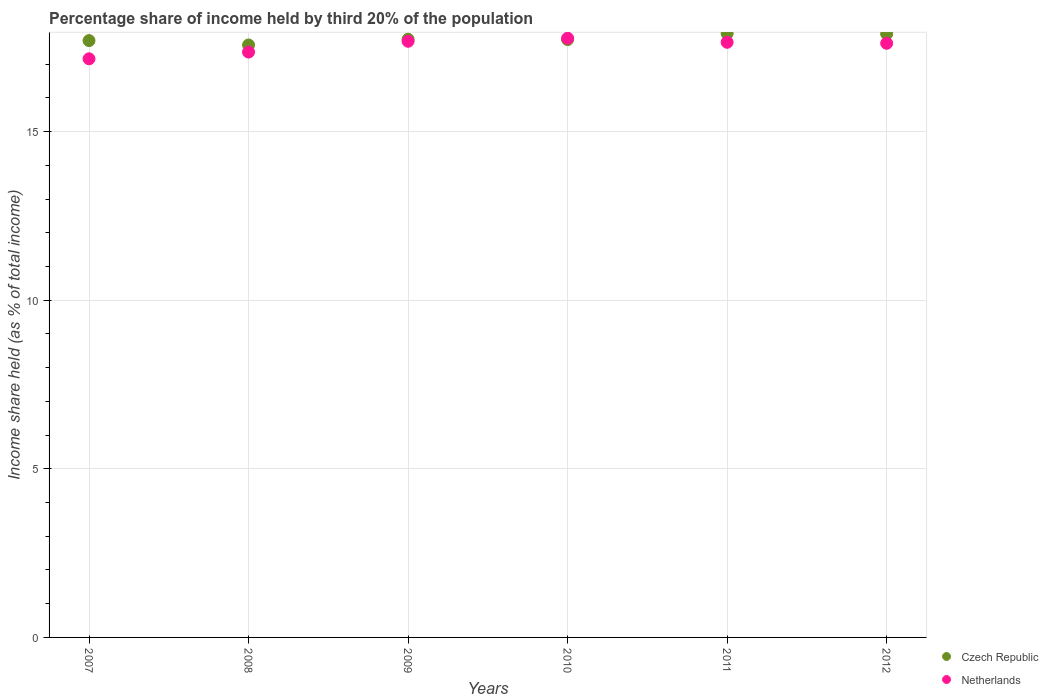Is the number of dotlines equal to the number of legend labels?
Ensure brevity in your answer.  Yes. What is the share of income held by third 20% of the population in Czech Republic in 2009?
Provide a succinct answer. 17.74. Across all years, what is the maximum share of income held by third 20% of the population in Czech Republic?
Your answer should be very brief. 17.91. Across all years, what is the minimum share of income held by third 20% of the population in Czech Republic?
Provide a short and direct response. 17.57. What is the total share of income held by third 20% of the population in Netherlands in the graph?
Make the answer very short. 105.24. What is the difference between the share of income held by third 20% of the population in Czech Republic in 2008 and that in 2010?
Your answer should be very brief. -0.16. What is the difference between the share of income held by third 20% of the population in Netherlands in 2008 and the share of income held by third 20% of the population in Czech Republic in 2009?
Your response must be concise. -0.38. What is the average share of income held by third 20% of the population in Netherlands per year?
Provide a succinct answer. 17.54. In the year 2010, what is the difference between the share of income held by third 20% of the population in Netherlands and share of income held by third 20% of the population in Czech Republic?
Ensure brevity in your answer.  0.04. What is the ratio of the share of income held by third 20% of the population in Netherlands in 2009 to that in 2010?
Offer a terse response. 0.99. Is the difference between the share of income held by third 20% of the population in Netherlands in 2007 and 2009 greater than the difference between the share of income held by third 20% of the population in Czech Republic in 2007 and 2009?
Offer a very short reply. No. What is the difference between the highest and the second highest share of income held by third 20% of the population in Netherlands?
Your response must be concise. 0.09. What is the difference between the highest and the lowest share of income held by third 20% of the population in Netherlands?
Ensure brevity in your answer.  0.61. Is the sum of the share of income held by third 20% of the population in Czech Republic in 2007 and 2012 greater than the maximum share of income held by third 20% of the population in Netherlands across all years?
Give a very brief answer. Yes. Is the share of income held by third 20% of the population in Czech Republic strictly less than the share of income held by third 20% of the population in Netherlands over the years?
Your answer should be compact. No. How many years are there in the graph?
Ensure brevity in your answer.  6. What is the difference between two consecutive major ticks on the Y-axis?
Your answer should be very brief. 5. Where does the legend appear in the graph?
Keep it short and to the point. Bottom right. How many legend labels are there?
Make the answer very short. 2. What is the title of the graph?
Offer a very short reply. Percentage share of income held by third 20% of the population. Does "Germany" appear as one of the legend labels in the graph?
Give a very brief answer. No. What is the label or title of the Y-axis?
Keep it short and to the point. Income share held (as % of total income). What is the Income share held (as % of total income) in Czech Republic in 2007?
Make the answer very short. 17.7. What is the Income share held (as % of total income) of Netherlands in 2007?
Make the answer very short. 17.16. What is the Income share held (as % of total income) in Czech Republic in 2008?
Keep it short and to the point. 17.57. What is the Income share held (as % of total income) in Netherlands in 2008?
Provide a succinct answer. 17.36. What is the Income share held (as % of total income) in Czech Republic in 2009?
Offer a very short reply. 17.74. What is the Income share held (as % of total income) in Netherlands in 2009?
Make the answer very short. 17.68. What is the Income share held (as % of total income) in Czech Republic in 2010?
Your answer should be compact. 17.73. What is the Income share held (as % of total income) in Netherlands in 2010?
Offer a very short reply. 17.77. What is the Income share held (as % of total income) in Czech Republic in 2011?
Ensure brevity in your answer.  17.91. What is the Income share held (as % of total income) in Netherlands in 2011?
Provide a short and direct response. 17.65. What is the Income share held (as % of total income) of Czech Republic in 2012?
Provide a short and direct response. 17.9. What is the Income share held (as % of total income) in Netherlands in 2012?
Your answer should be compact. 17.62. Across all years, what is the maximum Income share held (as % of total income) in Czech Republic?
Your answer should be very brief. 17.91. Across all years, what is the maximum Income share held (as % of total income) of Netherlands?
Make the answer very short. 17.77. Across all years, what is the minimum Income share held (as % of total income) of Czech Republic?
Make the answer very short. 17.57. Across all years, what is the minimum Income share held (as % of total income) of Netherlands?
Offer a terse response. 17.16. What is the total Income share held (as % of total income) of Czech Republic in the graph?
Make the answer very short. 106.55. What is the total Income share held (as % of total income) in Netherlands in the graph?
Keep it short and to the point. 105.24. What is the difference between the Income share held (as % of total income) of Czech Republic in 2007 and that in 2008?
Offer a terse response. 0.13. What is the difference between the Income share held (as % of total income) of Netherlands in 2007 and that in 2008?
Your response must be concise. -0.2. What is the difference between the Income share held (as % of total income) of Czech Republic in 2007 and that in 2009?
Make the answer very short. -0.04. What is the difference between the Income share held (as % of total income) in Netherlands in 2007 and that in 2009?
Ensure brevity in your answer.  -0.52. What is the difference between the Income share held (as % of total income) in Czech Republic in 2007 and that in 2010?
Your answer should be very brief. -0.03. What is the difference between the Income share held (as % of total income) of Netherlands in 2007 and that in 2010?
Give a very brief answer. -0.61. What is the difference between the Income share held (as % of total income) in Czech Republic in 2007 and that in 2011?
Ensure brevity in your answer.  -0.21. What is the difference between the Income share held (as % of total income) in Netherlands in 2007 and that in 2011?
Give a very brief answer. -0.49. What is the difference between the Income share held (as % of total income) of Netherlands in 2007 and that in 2012?
Provide a succinct answer. -0.46. What is the difference between the Income share held (as % of total income) in Czech Republic in 2008 and that in 2009?
Make the answer very short. -0.17. What is the difference between the Income share held (as % of total income) of Netherlands in 2008 and that in 2009?
Your answer should be compact. -0.32. What is the difference between the Income share held (as % of total income) of Czech Republic in 2008 and that in 2010?
Offer a very short reply. -0.16. What is the difference between the Income share held (as % of total income) of Netherlands in 2008 and that in 2010?
Your response must be concise. -0.41. What is the difference between the Income share held (as % of total income) in Czech Republic in 2008 and that in 2011?
Offer a very short reply. -0.34. What is the difference between the Income share held (as % of total income) of Netherlands in 2008 and that in 2011?
Your response must be concise. -0.29. What is the difference between the Income share held (as % of total income) of Czech Republic in 2008 and that in 2012?
Keep it short and to the point. -0.33. What is the difference between the Income share held (as % of total income) in Netherlands in 2008 and that in 2012?
Provide a succinct answer. -0.26. What is the difference between the Income share held (as % of total income) in Czech Republic in 2009 and that in 2010?
Offer a terse response. 0.01. What is the difference between the Income share held (as % of total income) of Netherlands in 2009 and that in 2010?
Provide a short and direct response. -0.09. What is the difference between the Income share held (as % of total income) of Czech Republic in 2009 and that in 2011?
Offer a very short reply. -0.17. What is the difference between the Income share held (as % of total income) in Czech Republic in 2009 and that in 2012?
Give a very brief answer. -0.16. What is the difference between the Income share held (as % of total income) of Netherlands in 2009 and that in 2012?
Offer a terse response. 0.06. What is the difference between the Income share held (as % of total income) in Czech Republic in 2010 and that in 2011?
Your answer should be very brief. -0.18. What is the difference between the Income share held (as % of total income) of Netherlands in 2010 and that in 2011?
Your answer should be very brief. 0.12. What is the difference between the Income share held (as % of total income) in Czech Republic in 2010 and that in 2012?
Provide a short and direct response. -0.17. What is the difference between the Income share held (as % of total income) of Netherlands in 2010 and that in 2012?
Your answer should be compact. 0.15. What is the difference between the Income share held (as % of total income) of Netherlands in 2011 and that in 2012?
Offer a very short reply. 0.03. What is the difference between the Income share held (as % of total income) of Czech Republic in 2007 and the Income share held (as % of total income) of Netherlands in 2008?
Give a very brief answer. 0.34. What is the difference between the Income share held (as % of total income) of Czech Republic in 2007 and the Income share held (as % of total income) of Netherlands in 2009?
Offer a very short reply. 0.02. What is the difference between the Income share held (as % of total income) in Czech Republic in 2007 and the Income share held (as % of total income) in Netherlands in 2010?
Ensure brevity in your answer.  -0.07. What is the difference between the Income share held (as % of total income) in Czech Republic in 2008 and the Income share held (as % of total income) in Netherlands in 2009?
Provide a short and direct response. -0.11. What is the difference between the Income share held (as % of total income) in Czech Republic in 2008 and the Income share held (as % of total income) in Netherlands in 2010?
Offer a terse response. -0.2. What is the difference between the Income share held (as % of total income) in Czech Republic in 2008 and the Income share held (as % of total income) in Netherlands in 2011?
Offer a terse response. -0.08. What is the difference between the Income share held (as % of total income) in Czech Republic in 2008 and the Income share held (as % of total income) in Netherlands in 2012?
Make the answer very short. -0.05. What is the difference between the Income share held (as % of total income) of Czech Republic in 2009 and the Income share held (as % of total income) of Netherlands in 2010?
Provide a short and direct response. -0.03. What is the difference between the Income share held (as % of total income) in Czech Republic in 2009 and the Income share held (as % of total income) in Netherlands in 2011?
Provide a succinct answer. 0.09. What is the difference between the Income share held (as % of total income) in Czech Republic in 2009 and the Income share held (as % of total income) in Netherlands in 2012?
Offer a terse response. 0.12. What is the difference between the Income share held (as % of total income) of Czech Republic in 2010 and the Income share held (as % of total income) of Netherlands in 2012?
Offer a very short reply. 0.11. What is the difference between the Income share held (as % of total income) of Czech Republic in 2011 and the Income share held (as % of total income) of Netherlands in 2012?
Your response must be concise. 0.29. What is the average Income share held (as % of total income) in Czech Republic per year?
Make the answer very short. 17.76. What is the average Income share held (as % of total income) in Netherlands per year?
Your response must be concise. 17.54. In the year 2007, what is the difference between the Income share held (as % of total income) of Czech Republic and Income share held (as % of total income) of Netherlands?
Your answer should be compact. 0.54. In the year 2008, what is the difference between the Income share held (as % of total income) of Czech Republic and Income share held (as % of total income) of Netherlands?
Ensure brevity in your answer.  0.21. In the year 2010, what is the difference between the Income share held (as % of total income) of Czech Republic and Income share held (as % of total income) of Netherlands?
Offer a terse response. -0.04. In the year 2011, what is the difference between the Income share held (as % of total income) of Czech Republic and Income share held (as % of total income) of Netherlands?
Keep it short and to the point. 0.26. In the year 2012, what is the difference between the Income share held (as % of total income) of Czech Republic and Income share held (as % of total income) of Netherlands?
Your answer should be very brief. 0.28. What is the ratio of the Income share held (as % of total income) in Czech Republic in 2007 to that in 2008?
Ensure brevity in your answer.  1.01. What is the ratio of the Income share held (as % of total income) in Netherlands in 2007 to that in 2008?
Your answer should be very brief. 0.99. What is the ratio of the Income share held (as % of total income) in Netherlands in 2007 to that in 2009?
Offer a terse response. 0.97. What is the ratio of the Income share held (as % of total income) of Czech Republic in 2007 to that in 2010?
Give a very brief answer. 1. What is the ratio of the Income share held (as % of total income) in Netherlands in 2007 to that in 2010?
Keep it short and to the point. 0.97. What is the ratio of the Income share held (as % of total income) of Czech Republic in 2007 to that in 2011?
Your response must be concise. 0.99. What is the ratio of the Income share held (as % of total income) of Netherlands in 2007 to that in 2011?
Ensure brevity in your answer.  0.97. What is the ratio of the Income share held (as % of total income) in Czech Republic in 2007 to that in 2012?
Provide a short and direct response. 0.99. What is the ratio of the Income share held (as % of total income) in Netherlands in 2007 to that in 2012?
Give a very brief answer. 0.97. What is the ratio of the Income share held (as % of total income) of Czech Republic in 2008 to that in 2009?
Your answer should be very brief. 0.99. What is the ratio of the Income share held (as % of total income) of Netherlands in 2008 to that in 2009?
Your answer should be very brief. 0.98. What is the ratio of the Income share held (as % of total income) in Netherlands in 2008 to that in 2010?
Provide a short and direct response. 0.98. What is the ratio of the Income share held (as % of total income) in Netherlands in 2008 to that in 2011?
Your answer should be compact. 0.98. What is the ratio of the Income share held (as % of total income) in Czech Republic in 2008 to that in 2012?
Ensure brevity in your answer.  0.98. What is the ratio of the Income share held (as % of total income) of Netherlands in 2008 to that in 2012?
Provide a succinct answer. 0.99. What is the ratio of the Income share held (as % of total income) of Netherlands in 2009 to that in 2012?
Your response must be concise. 1. What is the ratio of the Income share held (as % of total income) of Czech Republic in 2010 to that in 2011?
Keep it short and to the point. 0.99. What is the ratio of the Income share held (as % of total income) of Netherlands in 2010 to that in 2011?
Ensure brevity in your answer.  1.01. What is the ratio of the Income share held (as % of total income) of Netherlands in 2010 to that in 2012?
Keep it short and to the point. 1.01. What is the difference between the highest and the second highest Income share held (as % of total income) of Czech Republic?
Give a very brief answer. 0.01. What is the difference between the highest and the second highest Income share held (as % of total income) in Netherlands?
Provide a succinct answer. 0.09. What is the difference between the highest and the lowest Income share held (as % of total income) of Czech Republic?
Ensure brevity in your answer.  0.34. What is the difference between the highest and the lowest Income share held (as % of total income) of Netherlands?
Provide a short and direct response. 0.61. 